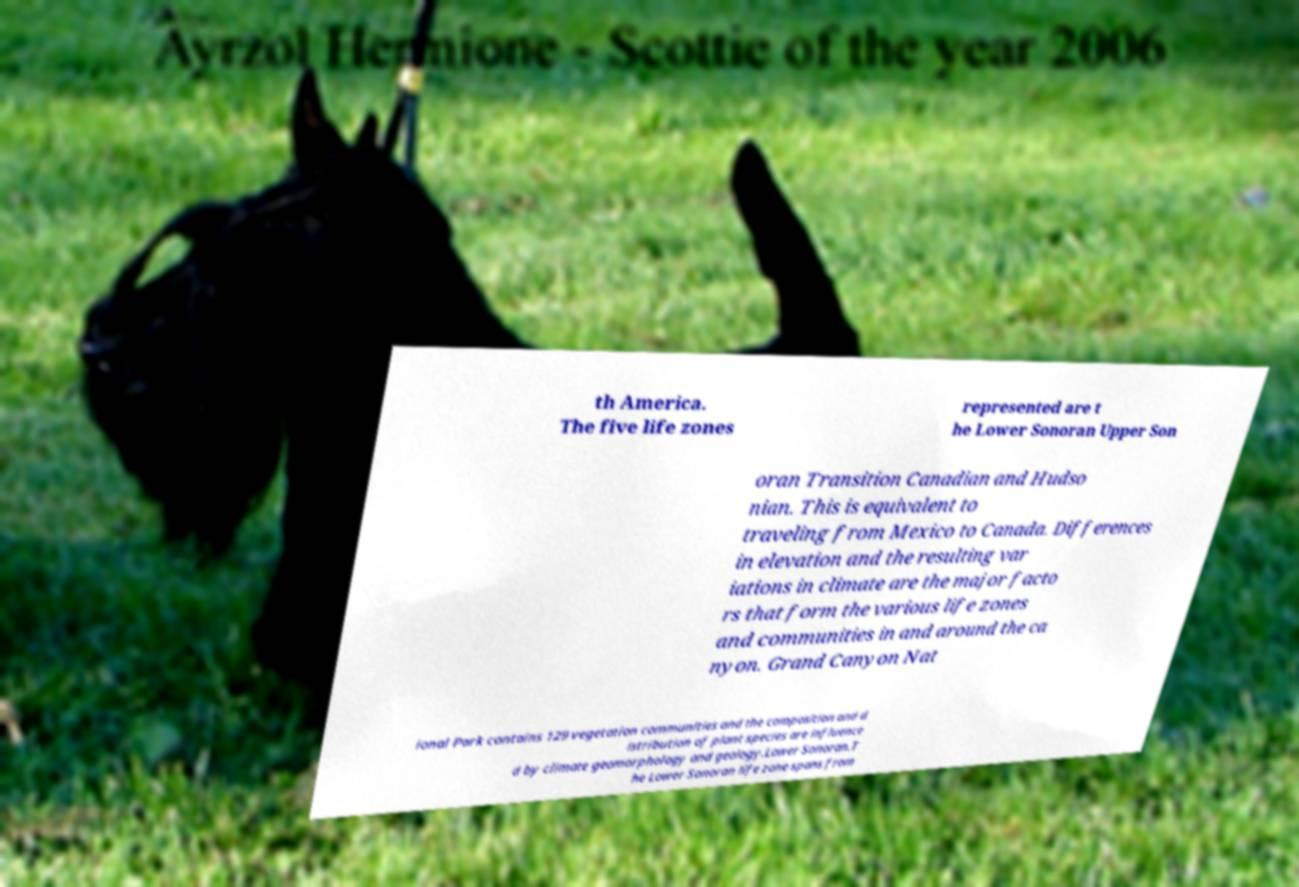Could you extract and type out the text from this image? th America. The five life zones represented are t he Lower Sonoran Upper Son oran Transition Canadian and Hudso nian. This is equivalent to traveling from Mexico to Canada. Differences in elevation and the resulting var iations in climate are the major facto rs that form the various life zones and communities in and around the ca nyon. Grand Canyon Nat ional Park contains 129 vegetation communities and the composition and d istribution of plant species are influence d by climate geomorphology and geology.Lower Sonoran.T he Lower Sonoran life zone spans from 